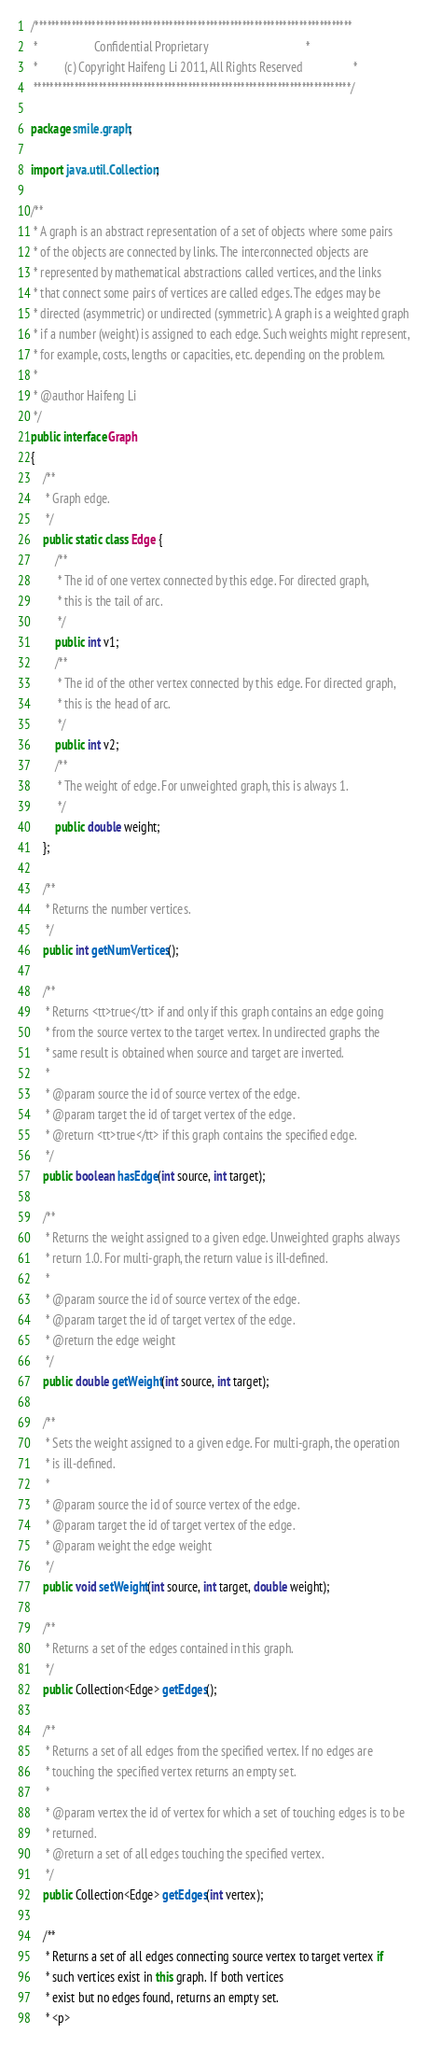Convert code to text. <code><loc_0><loc_0><loc_500><loc_500><_Java_>/******************************************************************************
 *                   Confidential Proprietary                                 *
 *         (c) Copyright Haifeng Li 2011, All Rights Reserved                 *
 ******************************************************************************/

package smile.graph;

import java.util.Collection;

/**
 * A graph is an abstract representation of a set of objects where some pairs
 * of the objects are connected by links. The interconnected objects are
 * represented by mathematical abstractions called vertices, and the links
 * that connect some pairs of vertices are called edges. The edges may be
 * directed (asymmetric) or undirected (symmetric). A graph is a weighted graph
 * if a number (weight) is assigned to each edge. Such weights might represent,
 * for example, costs, lengths or capacities, etc. depending on the problem.
 *
 * @author Haifeng Li
 */
public interface Graph
{
    /**
     * Graph edge.
     */
    public static class Edge {
        /**
         * The id of one vertex connected by this edge. For directed graph,
         * this is the tail of arc.
         */
        public int v1;
        /**
         * The id of the other vertex connected by this edge. For directed graph,
         * this is the head of arc.
         */
        public int v2;
        /**
         * The weight of edge. For unweighted graph, this is always 1.
         */
        public double weight;
    };

    /**
     * Returns the number vertices.
     */
    public int getNumVertices();

    /**
     * Returns <tt>true</tt> if and only if this graph contains an edge going
     * from the source vertex to the target vertex. In undirected graphs the
     * same result is obtained when source and target are inverted.
     *
     * @param source the id of source vertex of the edge.
     * @param target the id of target vertex of the edge.
     * @return <tt>true</tt> if this graph contains the specified edge.
     */
    public boolean hasEdge(int source, int target);

    /**
     * Returns the weight assigned to a given edge. Unweighted graphs always
     * return 1.0. For multi-graph, the return value is ill-defined.
     *
     * @param source the id of source vertex of the edge.
     * @param target the id of target vertex of the edge.
     * @return the edge weight
     */
    public double getWeight(int source, int target);

    /**
     * Sets the weight assigned to a given edge. For multi-graph, the operation
     * is ill-defined.
     *
     * @param source the id of source vertex of the edge.
     * @param target the id of target vertex of the edge.
     * @param weight the edge weight
     */
    public void setWeight(int source, int target, double weight);

    /**
     * Returns a set of the edges contained in this graph.
     */
    public Collection<Edge> getEdges();

    /**
     * Returns a set of all edges from the specified vertex. If no edges are
     * touching the specified vertex returns an empty set.
     *
     * @param vertex the id of vertex for which a set of touching edges is to be
     * returned.
     * @return a set of all edges touching the specified vertex.
     */
    public Collection<Edge> getEdges(int vertex);

    /**
     * Returns a set of all edges connecting source vertex to target vertex if
     * such vertices exist in this graph. If both vertices
     * exist but no edges found, returns an empty set.
     * <p></code> 